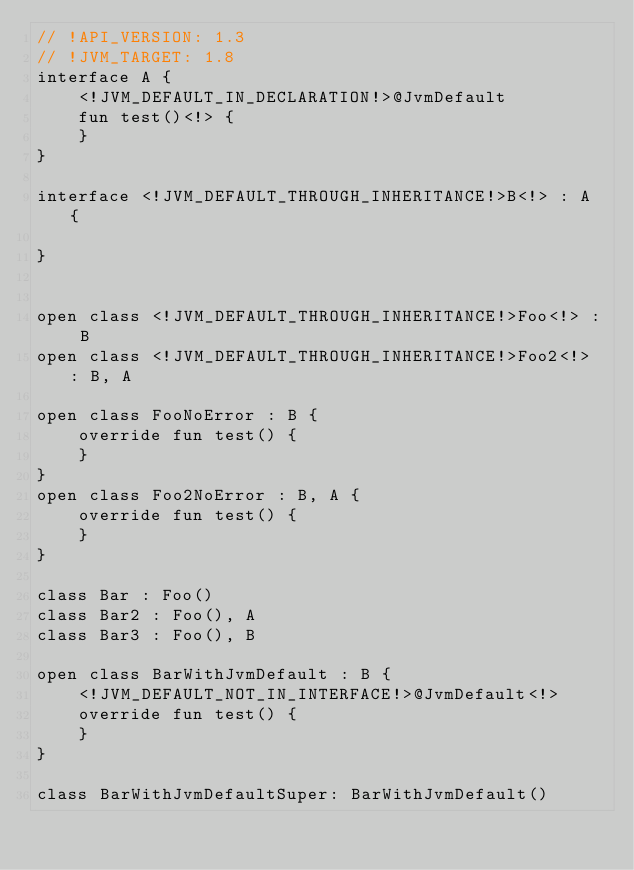Convert code to text. <code><loc_0><loc_0><loc_500><loc_500><_Kotlin_>// !API_VERSION: 1.3
// !JVM_TARGET: 1.8
interface A {
    <!JVM_DEFAULT_IN_DECLARATION!>@JvmDefault
    fun test()<!> {
    }
}

interface <!JVM_DEFAULT_THROUGH_INHERITANCE!>B<!> : A {

}


open class <!JVM_DEFAULT_THROUGH_INHERITANCE!>Foo<!> : B
open class <!JVM_DEFAULT_THROUGH_INHERITANCE!>Foo2<!> : B, A

open class FooNoError : B {
    override fun test() {
    }
}
open class Foo2NoError : B, A {
    override fun test() {
    }
}

class Bar : Foo()
class Bar2 : Foo(), A
class Bar3 : Foo(), B

open class BarWithJvmDefault : B {
    <!JVM_DEFAULT_NOT_IN_INTERFACE!>@JvmDefault<!>
    override fun test() {
    }
}

class BarWithJvmDefaultSuper: BarWithJvmDefault()</code> 